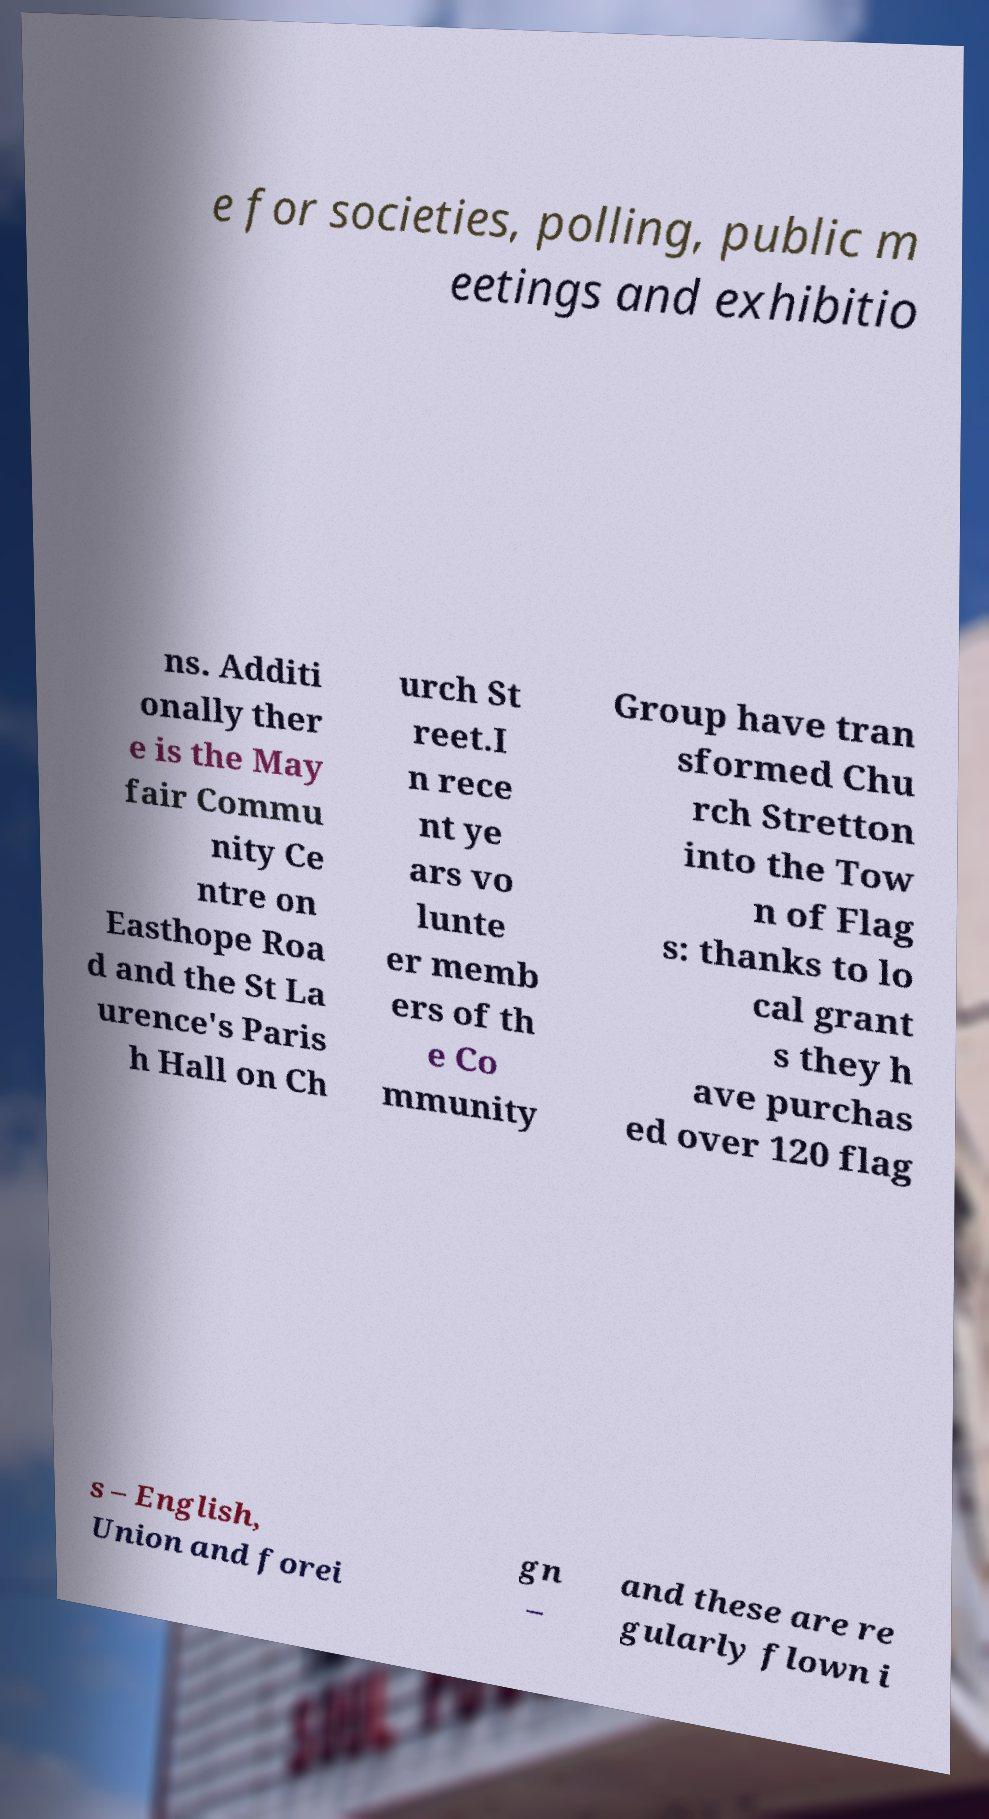Can you accurately transcribe the text from the provided image for me? e for societies, polling, public m eetings and exhibitio ns. Additi onally ther e is the May fair Commu nity Ce ntre on Easthope Roa d and the St La urence's Paris h Hall on Ch urch St reet.I n rece nt ye ars vo lunte er memb ers of th e Co mmunity Group have tran sformed Chu rch Stretton into the Tow n of Flag s: thanks to lo cal grant s they h ave purchas ed over 120 flag s – English, Union and forei gn – and these are re gularly flown i 